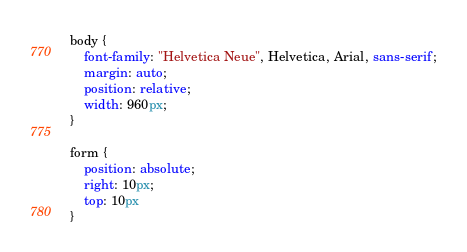Convert code to text. <code><loc_0><loc_0><loc_500><loc_500><_CSS_>body {
	font-family: "Helvetica Neue", Helvetica, Arial, sans-serif;
	margin: auto;
	position: relative;
	width: 960px;
}

form {
	position: absolute;
	right: 10px;
	top: 10px
}</code> 